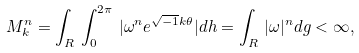Convert formula to latex. <formula><loc_0><loc_0><loc_500><loc_500>M ^ { n } _ { k } = \int _ { R } \, \int ^ { 2 \pi } _ { 0 } \, | \omega ^ { n } e ^ { \sqrt { - 1 } k \theta } | d h = \int _ { R } \, | \omega | ^ { n } d g < \infty ,</formula> 